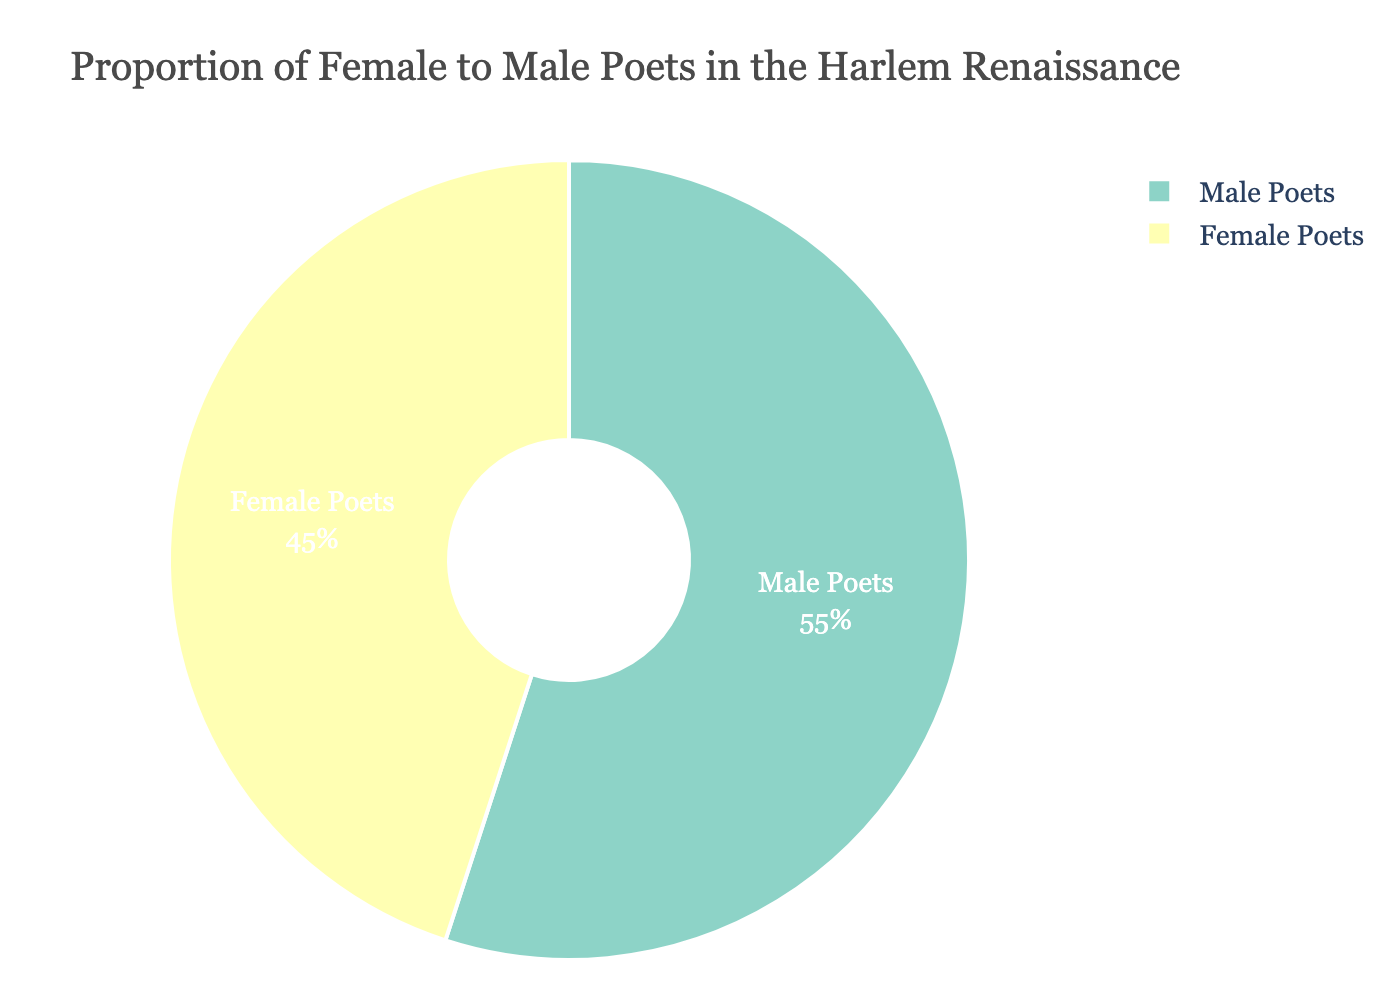What is the percentage of female poets represented in the Harlem Renaissance according to the pie chart? The pie chart indicates that the percentage of female poets in the Harlem Renaissance is labeled directly on the chart. The labeled segment of the pie chart for female poets shows 45%.
Answer: 45% How much higher is the percentage of male poets compared to female poets? The percentage of male poets is 55% and the percentage of female poets is 45%. Subtracting the percentage of female poets from male poets gives 55% - 45% = 10%.
Answer: 10% What is the combined percentage of both female and male poets? The pie chart represents the entire distribution of poets, so the combined percentage must sum to 100%. Adding female poets (45%) and male poets (55%) results in 45% + 55% = 100%.
Answer: 100% Which gender had a higher representation in the Harlem Renaissance, and by what margin? By comparing the percentages shown in the pie chart, male poets have a higher representation at 55%, while female poets have 45%. The difference is 55% - 45% = 10%.
Answer: Male by 10% What colors are used to represent female and male poets in the pie chart? The pie chart uses different colors for each gender, as indicated by the segments. Female poets are represented in one color, and male poets in another. The specific colors can be identified directly from the visual of the pie chart segments.
Answer: Specific colors based on chart How much of the total representation do female poets contribute if male poets contribute 55%? Given that male poets contribute 55% and the entire pie chart represents 100%, female poets contribute the remaining portion. Therefore, 100% - 55% = 45%.
Answer: 45% Is the difference in representation between male and female poets less than, more than, or equal to 15%? The difference in representation can be found by subtracting the female poets' percentage from the male poets' percentage: 55% - 45% = 10%. Since 10% is less than 15%, the difference is less than 15%.
Answer: Less than If the pie chart were divided into quadrants, would the segment for female poets be more, less than, or equal to one quadrant? A quadrant represents 25% of the pie chart. Since female poets constitute 45%, their segment is more than one quadrant, which is more significant than 25%.
Answer: More What is the proportion of female poets to male poets in decimal form? The percentage of female poets is 45%, and male poets is 55%. To find the proportion in decimal form, divide the female percentage by the male percentage: 45% / 55% = 0.818.
Answer: 0.82 If we assume there were 200 poets in total during the Harlem Renaissance, how many of them were female? If 45% of the poets were female, then the number of female poets can be calculated as 45% of 200. Thus, 0.45 * 200 = 90 female poets.
Answer: 90 